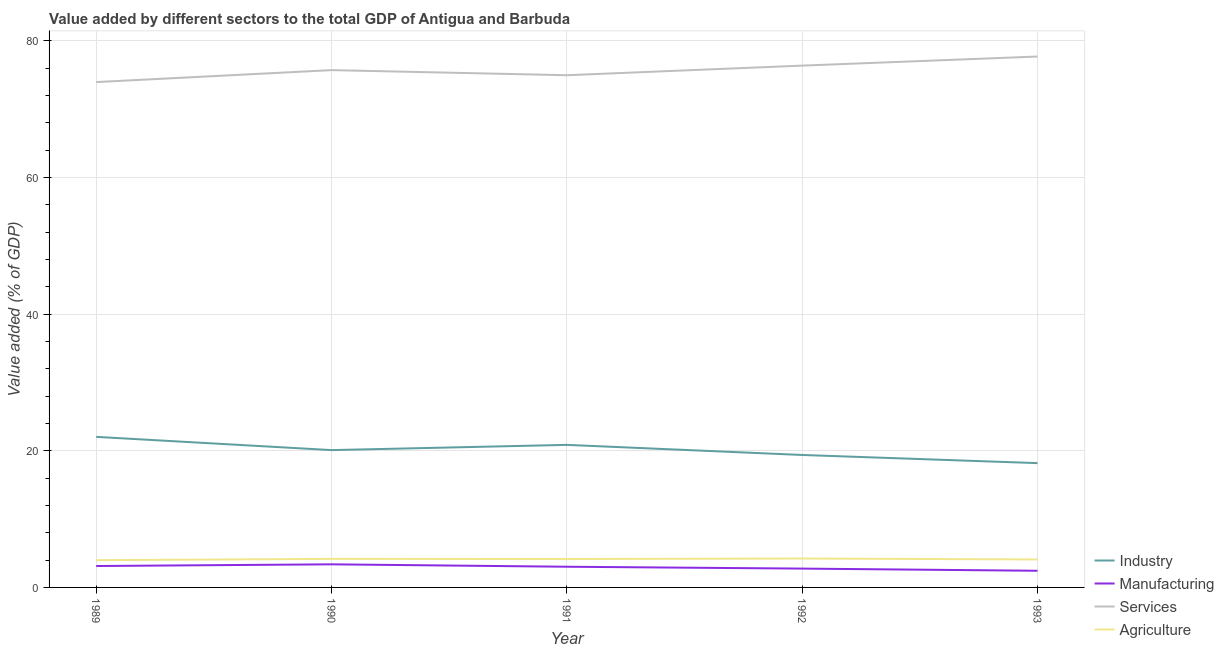How many different coloured lines are there?
Offer a terse response. 4. Does the line corresponding to value added by agricultural sector intersect with the line corresponding to value added by manufacturing sector?
Your response must be concise. No. What is the value added by manufacturing sector in 1990?
Offer a terse response. 3.38. Across all years, what is the maximum value added by manufacturing sector?
Provide a short and direct response. 3.38. Across all years, what is the minimum value added by services sector?
Provide a succinct answer. 73.97. In which year was the value added by services sector maximum?
Keep it short and to the point. 1993. What is the total value added by industrial sector in the graph?
Give a very brief answer. 100.59. What is the difference between the value added by agricultural sector in 1990 and that in 1993?
Your response must be concise. 0.08. What is the difference between the value added by services sector in 1989 and the value added by agricultural sector in 1990?
Your response must be concise. 69.79. What is the average value added by services sector per year?
Your answer should be compact. 75.75. In the year 1991, what is the difference between the value added by industrial sector and value added by agricultural sector?
Ensure brevity in your answer.  16.71. What is the ratio of the value added by services sector in 1990 to that in 1992?
Ensure brevity in your answer.  0.99. What is the difference between the highest and the second highest value added by agricultural sector?
Your answer should be very brief. 0.05. What is the difference between the highest and the lowest value added by industrial sector?
Provide a succinct answer. 3.84. Is it the case that in every year, the sum of the value added by manufacturing sector and value added by industrial sector is greater than the sum of value added by services sector and value added by agricultural sector?
Your answer should be very brief. Yes. Is it the case that in every year, the sum of the value added by industrial sector and value added by manufacturing sector is greater than the value added by services sector?
Ensure brevity in your answer.  No. Does the value added by manufacturing sector monotonically increase over the years?
Keep it short and to the point. No. Is the value added by services sector strictly greater than the value added by manufacturing sector over the years?
Your answer should be compact. Yes. How many years are there in the graph?
Your answer should be very brief. 5. What is the difference between two consecutive major ticks on the Y-axis?
Provide a succinct answer. 20. Does the graph contain any zero values?
Offer a terse response. No. How many legend labels are there?
Your answer should be very brief. 4. What is the title of the graph?
Give a very brief answer. Value added by different sectors to the total GDP of Antigua and Barbuda. Does "International Monetary Fund" appear as one of the legend labels in the graph?
Your answer should be very brief. No. What is the label or title of the Y-axis?
Your response must be concise. Value added (% of GDP). What is the Value added (% of GDP) of Industry in 1989?
Give a very brief answer. 22.04. What is the Value added (% of GDP) in Manufacturing in 1989?
Your answer should be very brief. 3.13. What is the Value added (% of GDP) in Services in 1989?
Provide a short and direct response. 73.97. What is the Value added (% of GDP) of Agriculture in 1989?
Your answer should be compact. 3.99. What is the Value added (% of GDP) of Industry in 1990?
Keep it short and to the point. 20.1. What is the Value added (% of GDP) in Manufacturing in 1990?
Offer a very short reply. 3.38. What is the Value added (% of GDP) of Services in 1990?
Ensure brevity in your answer.  75.72. What is the Value added (% of GDP) of Agriculture in 1990?
Offer a very short reply. 4.18. What is the Value added (% of GDP) in Industry in 1991?
Make the answer very short. 20.87. What is the Value added (% of GDP) of Manufacturing in 1991?
Provide a short and direct response. 3.03. What is the Value added (% of GDP) of Services in 1991?
Provide a succinct answer. 74.98. What is the Value added (% of GDP) of Agriculture in 1991?
Make the answer very short. 4.16. What is the Value added (% of GDP) in Industry in 1992?
Your response must be concise. 19.39. What is the Value added (% of GDP) of Manufacturing in 1992?
Give a very brief answer. 2.76. What is the Value added (% of GDP) in Services in 1992?
Keep it short and to the point. 76.38. What is the Value added (% of GDP) in Agriculture in 1992?
Give a very brief answer. 4.23. What is the Value added (% of GDP) of Industry in 1993?
Provide a succinct answer. 18.19. What is the Value added (% of GDP) in Manufacturing in 1993?
Keep it short and to the point. 2.44. What is the Value added (% of GDP) of Services in 1993?
Keep it short and to the point. 77.71. What is the Value added (% of GDP) of Agriculture in 1993?
Ensure brevity in your answer.  4.1. Across all years, what is the maximum Value added (% of GDP) of Industry?
Offer a terse response. 22.04. Across all years, what is the maximum Value added (% of GDP) in Manufacturing?
Ensure brevity in your answer.  3.38. Across all years, what is the maximum Value added (% of GDP) of Services?
Your answer should be very brief. 77.71. Across all years, what is the maximum Value added (% of GDP) of Agriculture?
Your answer should be very brief. 4.23. Across all years, what is the minimum Value added (% of GDP) of Industry?
Your answer should be very brief. 18.19. Across all years, what is the minimum Value added (% of GDP) of Manufacturing?
Ensure brevity in your answer.  2.44. Across all years, what is the minimum Value added (% of GDP) of Services?
Offer a very short reply. 73.97. Across all years, what is the minimum Value added (% of GDP) in Agriculture?
Offer a very short reply. 3.99. What is the total Value added (% of GDP) of Industry in the graph?
Offer a terse response. 100.59. What is the total Value added (% of GDP) of Manufacturing in the graph?
Offer a very short reply. 14.74. What is the total Value added (% of GDP) in Services in the graph?
Provide a short and direct response. 378.76. What is the total Value added (% of GDP) of Agriculture in the graph?
Your answer should be very brief. 20.65. What is the difference between the Value added (% of GDP) in Industry in 1989 and that in 1990?
Offer a terse response. 1.94. What is the difference between the Value added (% of GDP) of Manufacturing in 1989 and that in 1990?
Offer a very short reply. -0.25. What is the difference between the Value added (% of GDP) of Services in 1989 and that in 1990?
Your answer should be compact. -1.75. What is the difference between the Value added (% of GDP) of Agriculture in 1989 and that in 1990?
Your answer should be compact. -0.19. What is the difference between the Value added (% of GDP) of Industry in 1989 and that in 1991?
Ensure brevity in your answer.  1.17. What is the difference between the Value added (% of GDP) of Manufacturing in 1989 and that in 1991?
Your answer should be very brief. 0.11. What is the difference between the Value added (% of GDP) in Services in 1989 and that in 1991?
Your answer should be very brief. -1. What is the difference between the Value added (% of GDP) of Agriculture in 1989 and that in 1991?
Give a very brief answer. -0.17. What is the difference between the Value added (% of GDP) of Industry in 1989 and that in 1992?
Your response must be concise. 2.65. What is the difference between the Value added (% of GDP) of Manufacturing in 1989 and that in 1992?
Offer a terse response. 0.38. What is the difference between the Value added (% of GDP) in Services in 1989 and that in 1992?
Offer a terse response. -2.41. What is the difference between the Value added (% of GDP) in Agriculture in 1989 and that in 1992?
Offer a very short reply. -0.24. What is the difference between the Value added (% of GDP) of Industry in 1989 and that in 1993?
Offer a very short reply. 3.84. What is the difference between the Value added (% of GDP) of Manufacturing in 1989 and that in 1993?
Give a very brief answer. 0.7. What is the difference between the Value added (% of GDP) in Services in 1989 and that in 1993?
Offer a terse response. -3.74. What is the difference between the Value added (% of GDP) of Agriculture in 1989 and that in 1993?
Make the answer very short. -0.11. What is the difference between the Value added (% of GDP) of Industry in 1990 and that in 1991?
Make the answer very short. -0.77. What is the difference between the Value added (% of GDP) of Manufacturing in 1990 and that in 1991?
Keep it short and to the point. 0.35. What is the difference between the Value added (% of GDP) in Services in 1990 and that in 1991?
Your response must be concise. 0.74. What is the difference between the Value added (% of GDP) in Agriculture in 1990 and that in 1991?
Give a very brief answer. 0.02. What is the difference between the Value added (% of GDP) in Industry in 1990 and that in 1992?
Your answer should be very brief. 0.71. What is the difference between the Value added (% of GDP) of Manufacturing in 1990 and that in 1992?
Provide a succinct answer. 0.62. What is the difference between the Value added (% of GDP) of Services in 1990 and that in 1992?
Ensure brevity in your answer.  -0.66. What is the difference between the Value added (% of GDP) in Agriculture in 1990 and that in 1992?
Provide a short and direct response. -0.05. What is the difference between the Value added (% of GDP) in Industry in 1990 and that in 1993?
Give a very brief answer. 1.91. What is the difference between the Value added (% of GDP) of Manufacturing in 1990 and that in 1993?
Ensure brevity in your answer.  0.94. What is the difference between the Value added (% of GDP) of Services in 1990 and that in 1993?
Give a very brief answer. -1.99. What is the difference between the Value added (% of GDP) in Agriculture in 1990 and that in 1993?
Give a very brief answer. 0.08. What is the difference between the Value added (% of GDP) in Industry in 1991 and that in 1992?
Keep it short and to the point. 1.48. What is the difference between the Value added (% of GDP) of Manufacturing in 1991 and that in 1992?
Your answer should be compact. 0.27. What is the difference between the Value added (% of GDP) in Services in 1991 and that in 1992?
Provide a succinct answer. -1.4. What is the difference between the Value added (% of GDP) of Agriculture in 1991 and that in 1992?
Give a very brief answer. -0.07. What is the difference between the Value added (% of GDP) in Industry in 1991 and that in 1993?
Your answer should be very brief. 2.67. What is the difference between the Value added (% of GDP) in Manufacturing in 1991 and that in 1993?
Offer a terse response. 0.59. What is the difference between the Value added (% of GDP) in Services in 1991 and that in 1993?
Provide a succinct answer. -2.73. What is the difference between the Value added (% of GDP) in Agriculture in 1991 and that in 1993?
Your response must be concise. 0.06. What is the difference between the Value added (% of GDP) in Industry in 1992 and that in 1993?
Keep it short and to the point. 1.19. What is the difference between the Value added (% of GDP) of Manufacturing in 1992 and that in 1993?
Make the answer very short. 0.32. What is the difference between the Value added (% of GDP) of Services in 1992 and that in 1993?
Make the answer very short. -1.33. What is the difference between the Value added (% of GDP) of Agriculture in 1992 and that in 1993?
Give a very brief answer. 0.14. What is the difference between the Value added (% of GDP) in Industry in 1989 and the Value added (% of GDP) in Manufacturing in 1990?
Ensure brevity in your answer.  18.66. What is the difference between the Value added (% of GDP) of Industry in 1989 and the Value added (% of GDP) of Services in 1990?
Keep it short and to the point. -53.68. What is the difference between the Value added (% of GDP) in Industry in 1989 and the Value added (% of GDP) in Agriculture in 1990?
Provide a succinct answer. 17.86. What is the difference between the Value added (% of GDP) in Manufacturing in 1989 and the Value added (% of GDP) in Services in 1990?
Your response must be concise. -72.59. What is the difference between the Value added (% of GDP) in Manufacturing in 1989 and the Value added (% of GDP) in Agriculture in 1990?
Make the answer very short. -1.04. What is the difference between the Value added (% of GDP) of Services in 1989 and the Value added (% of GDP) of Agriculture in 1990?
Give a very brief answer. 69.79. What is the difference between the Value added (% of GDP) of Industry in 1989 and the Value added (% of GDP) of Manufacturing in 1991?
Make the answer very short. 19.01. What is the difference between the Value added (% of GDP) in Industry in 1989 and the Value added (% of GDP) in Services in 1991?
Offer a very short reply. -52.94. What is the difference between the Value added (% of GDP) of Industry in 1989 and the Value added (% of GDP) of Agriculture in 1991?
Give a very brief answer. 17.88. What is the difference between the Value added (% of GDP) in Manufacturing in 1989 and the Value added (% of GDP) in Services in 1991?
Provide a succinct answer. -71.84. What is the difference between the Value added (% of GDP) in Manufacturing in 1989 and the Value added (% of GDP) in Agriculture in 1991?
Offer a terse response. -1.02. What is the difference between the Value added (% of GDP) in Services in 1989 and the Value added (% of GDP) in Agriculture in 1991?
Make the answer very short. 69.81. What is the difference between the Value added (% of GDP) of Industry in 1989 and the Value added (% of GDP) of Manufacturing in 1992?
Your answer should be very brief. 19.28. What is the difference between the Value added (% of GDP) in Industry in 1989 and the Value added (% of GDP) in Services in 1992?
Give a very brief answer. -54.34. What is the difference between the Value added (% of GDP) in Industry in 1989 and the Value added (% of GDP) in Agriculture in 1992?
Your answer should be very brief. 17.81. What is the difference between the Value added (% of GDP) of Manufacturing in 1989 and the Value added (% of GDP) of Services in 1992?
Offer a very short reply. -73.25. What is the difference between the Value added (% of GDP) of Manufacturing in 1989 and the Value added (% of GDP) of Agriculture in 1992?
Your answer should be very brief. -1.1. What is the difference between the Value added (% of GDP) of Services in 1989 and the Value added (% of GDP) of Agriculture in 1992?
Give a very brief answer. 69.74. What is the difference between the Value added (% of GDP) of Industry in 1989 and the Value added (% of GDP) of Manufacturing in 1993?
Offer a very short reply. 19.6. What is the difference between the Value added (% of GDP) of Industry in 1989 and the Value added (% of GDP) of Services in 1993?
Ensure brevity in your answer.  -55.67. What is the difference between the Value added (% of GDP) of Industry in 1989 and the Value added (% of GDP) of Agriculture in 1993?
Ensure brevity in your answer.  17.94. What is the difference between the Value added (% of GDP) of Manufacturing in 1989 and the Value added (% of GDP) of Services in 1993?
Offer a terse response. -74.58. What is the difference between the Value added (% of GDP) of Manufacturing in 1989 and the Value added (% of GDP) of Agriculture in 1993?
Your answer should be compact. -0.96. What is the difference between the Value added (% of GDP) in Services in 1989 and the Value added (% of GDP) in Agriculture in 1993?
Keep it short and to the point. 69.88. What is the difference between the Value added (% of GDP) in Industry in 1990 and the Value added (% of GDP) in Manufacturing in 1991?
Your answer should be very brief. 17.07. What is the difference between the Value added (% of GDP) of Industry in 1990 and the Value added (% of GDP) of Services in 1991?
Your answer should be compact. -54.88. What is the difference between the Value added (% of GDP) in Industry in 1990 and the Value added (% of GDP) in Agriculture in 1991?
Your answer should be very brief. 15.94. What is the difference between the Value added (% of GDP) in Manufacturing in 1990 and the Value added (% of GDP) in Services in 1991?
Make the answer very short. -71.6. What is the difference between the Value added (% of GDP) of Manufacturing in 1990 and the Value added (% of GDP) of Agriculture in 1991?
Make the answer very short. -0.78. What is the difference between the Value added (% of GDP) of Services in 1990 and the Value added (% of GDP) of Agriculture in 1991?
Offer a terse response. 71.56. What is the difference between the Value added (% of GDP) in Industry in 1990 and the Value added (% of GDP) in Manufacturing in 1992?
Give a very brief answer. 17.34. What is the difference between the Value added (% of GDP) in Industry in 1990 and the Value added (% of GDP) in Services in 1992?
Your response must be concise. -56.28. What is the difference between the Value added (% of GDP) in Industry in 1990 and the Value added (% of GDP) in Agriculture in 1992?
Your answer should be compact. 15.87. What is the difference between the Value added (% of GDP) in Manufacturing in 1990 and the Value added (% of GDP) in Services in 1992?
Make the answer very short. -73. What is the difference between the Value added (% of GDP) in Manufacturing in 1990 and the Value added (% of GDP) in Agriculture in 1992?
Your response must be concise. -0.85. What is the difference between the Value added (% of GDP) in Services in 1990 and the Value added (% of GDP) in Agriculture in 1992?
Your answer should be very brief. 71.49. What is the difference between the Value added (% of GDP) of Industry in 1990 and the Value added (% of GDP) of Manufacturing in 1993?
Keep it short and to the point. 17.66. What is the difference between the Value added (% of GDP) of Industry in 1990 and the Value added (% of GDP) of Services in 1993?
Ensure brevity in your answer.  -57.61. What is the difference between the Value added (% of GDP) in Industry in 1990 and the Value added (% of GDP) in Agriculture in 1993?
Give a very brief answer. 16.01. What is the difference between the Value added (% of GDP) of Manufacturing in 1990 and the Value added (% of GDP) of Services in 1993?
Offer a terse response. -74.33. What is the difference between the Value added (% of GDP) of Manufacturing in 1990 and the Value added (% of GDP) of Agriculture in 1993?
Offer a terse response. -0.71. What is the difference between the Value added (% of GDP) of Services in 1990 and the Value added (% of GDP) of Agriculture in 1993?
Offer a terse response. 71.63. What is the difference between the Value added (% of GDP) of Industry in 1991 and the Value added (% of GDP) of Manufacturing in 1992?
Provide a short and direct response. 18.11. What is the difference between the Value added (% of GDP) of Industry in 1991 and the Value added (% of GDP) of Services in 1992?
Keep it short and to the point. -55.51. What is the difference between the Value added (% of GDP) in Industry in 1991 and the Value added (% of GDP) in Agriculture in 1992?
Offer a very short reply. 16.64. What is the difference between the Value added (% of GDP) in Manufacturing in 1991 and the Value added (% of GDP) in Services in 1992?
Keep it short and to the point. -73.35. What is the difference between the Value added (% of GDP) of Manufacturing in 1991 and the Value added (% of GDP) of Agriculture in 1992?
Your answer should be very brief. -1.2. What is the difference between the Value added (% of GDP) in Services in 1991 and the Value added (% of GDP) in Agriculture in 1992?
Make the answer very short. 70.75. What is the difference between the Value added (% of GDP) of Industry in 1991 and the Value added (% of GDP) of Manufacturing in 1993?
Keep it short and to the point. 18.43. What is the difference between the Value added (% of GDP) in Industry in 1991 and the Value added (% of GDP) in Services in 1993?
Offer a very short reply. -56.84. What is the difference between the Value added (% of GDP) of Industry in 1991 and the Value added (% of GDP) of Agriculture in 1993?
Offer a very short reply. 16.77. What is the difference between the Value added (% of GDP) in Manufacturing in 1991 and the Value added (% of GDP) in Services in 1993?
Make the answer very short. -74.68. What is the difference between the Value added (% of GDP) in Manufacturing in 1991 and the Value added (% of GDP) in Agriculture in 1993?
Make the answer very short. -1.07. What is the difference between the Value added (% of GDP) in Services in 1991 and the Value added (% of GDP) in Agriculture in 1993?
Make the answer very short. 70.88. What is the difference between the Value added (% of GDP) in Industry in 1992 and the Value added (% of GDP) in Manufacturing in 1993?
Offer a terse response. 16.95. What is the difference between the Value added (% of GDP) in Industry in 1992 and the Value added (% of GDP) in Services in 1993?
Ensure brevity in your answer.  -58.32. What is the difference between the Value added (% of GDP) of Industry in 1992 and the Value added (% of GDP) of Agriculture in 1993?
Your answer should be compact. 15.29. What is the difference between the Value added (% of GDP) in Manufacturing in 1992 and the Value added (% of GDP) in Services in 1993?
Make the answer very short. -74.95. What is the difference between the Value added (% of GDP) of Manufacturing in 1992 and the Value added (% of GDP) of Agriculture in 1993?
Provide a short and direct response. -1.34. What is the difference between the Value added (% of GDP) of Services in 1992 and the Value added (% of GDP) of Agriculture in 1993?
Keep it short and to the point. 72.29. What is the average Value added (% of GDP) in Industry per year?
Provide a short and direct response. 20.12. What is the average Value added (% of GDP) in Manufacturing per year?
Your answer should be very brief. 2.95. What is the average Value added (% of GDP) of Services per year?
Keep it short and to the point. 75.75. What is the average Value added (% of GDP) in Agriculture per year?
Provide a succinct answer. 4.13. In the year 1989, what is the difference between the Value added (% of GDP) of Industry and Value added (% of GDP) of Manufacturing?
Offer a terse response. 18.9. In the year 1989, what is the difference between the Value added (% of GDP) in Industry and Value added (% of GDP) in Services?
Make the answer very short. -51.93. In the year 1989, what is the difference between the Value added (% of GDP) in Industry and Value added (% of GDP) in Agriculture?
Provide a short and direct response. 18.05. In the year 1989, what is the difference between the Value added (% of GDP) in Manufacturing and Value added (% of GDP) in Services?
Provide a succinct answer. -70.84. In the year 1989, what is the difference between the Value added (% of GDP) in Manufacturing and Value added (% of GDP) in Agriculture?
Your response must be concise. -0.86. In the year 1989, what is the difference between the Value added (% of GDP) of Services and Value added (% of GDP) of Agriculture?
Provide a short and direct response. 69.98. In the year 1990, what is the difference between the Value added (% of GDP) of Industry and Value added (% of GDP) of Manufacturing?
Offer a very short reply. 16.72. In the year 1990, what is the difference between the Value added (% of GDP) in Industry and Value added (% of GDP) in Services?
Give a very brief answer. -55.62. In the year 1990, what is the difference between the Value added (% of GDP) of Industry and Value added (% of GDP) of Agriculture?
Provide a succinct answer. 15.92. In the year 1990, what is the difference between the Value added (% of GDP) in Manufacturing and Value added (% of GDP) in Services?
Provide a short and direct response. -72.34. In the year 1990, what is the difference between the Value added (% of GDP) of Manufacturing and Value added (% of GDP) of Agriculture?
Ensure brevity in your answer.  -0.8. In the year 1990, what is the difference between the Value added (% of GDP) of Services and Value added (% of GDP) of Agriculture?
Give a very brief answer. 71.54. In the year 1991, what is the difference between the Value added (% of GDP) in Industry and Value added (% of GDP) in Manufacturing?
Ensure brevity in your answer.  17.84. In the year 1991, what is the difference between the Value added (% of GDP) in Industry and Value added (% of GDP) in Services?
Make the answer very short. -54.11. In the year 1991, what is the difference between the Value added (% of GDP) of Industry and Value added (% of GDP) of Agriculture?
Keep it short and to the point. 16.71. In the year 1991, what is the difference between the Value added (% of GDP) of Manufacturing and Value added (% of GDP) of Services?
Provide a short and direct response. -71.95. In the year 1991, what is the difference between the Value added (% of GDP) in Manufacturing and Value added (% of GDP) in Agriculture?
Give a very brief answer. -1.13. In the year 1991, what is the difference between the Value added (% of GDP) of Services and Value added (% of GDP) of Agriculture?
Give a very brief answer. 70.82. In the year 1992, what is the difference between the Value added (% of GDP) of Industry and Value added (% of GDP) of Manufacturing?
Provide a succinct answer. 16.63. In the year 1992, what is the difference between the Value added (% of GDP) of Industry and Value added (% of GDP) of Services?
Offer a terse response. -56.99. In the year 1992, what is the difference between the Value added (% of GDP) in Industry and Value added (% of GDP) in Agriculture?
Provide a short and direct response. 15.16. In the year 1992, what is the difference between the Value added (% of GDP) of Manufacturing and Value added (% of GDP) of Services?
Your answer should be compact. -73.62. In the year 1992, what is the difference between the Value added (% of GDP) of Manufacturing and Value added (% of GDP) of Agriculture?
Keep it short and to the point. -1.47. In the year 1992, what is the difference between the Value added (% of GDP) in Services and Value added (% of GDP) in Agriculture?
Offer a terse response. 72.15. In the year 1993, what is the difference between the Value added (% of GDP) of Industry and Value added (% of GDP) of Manufacturing?
Give a very brief answer. 15.76. In the year 1993, what is the difference between the Value added (% of GDP) in Industry and Value added (% of GDP) in Services?
Keep it short and to the point. -59.52. In the year 1993, what is the difference between the Value added (% of GDP) of Industry and Value added (% of GDP) of Agriculture?
Keep it short and to the point. 14.1. In the year 1993, what is the difference between the Value added (% of GDP) in Manufacturing and Value added (% of GDP) in Services?
Your answer should be very brief. -75.27. In the year 1993, what is the difference between the Value added (% of GDP) in Manufacturing and Value added (% of GDP) in Agriculture?
Offer a very short reply. -1.66. In the year 1993, what is the difference between the Value added (% of GDP) in Services and Value added (% of GDP) in Agriculture?
Make the answer very short. 73.61. What is the ratio of the Value added (% of GDP) in Industry in 1989 to that in 1990?
Ensure brevity in your answer.  1.1. What is the ratio of the Value added (% of GDP) in Manufacturing in 1989 to that in 1990?
Make the answer very short. 0.93. What is the ratio of the Value added (% of GDP) of Services in 1989 to that in 1990?
Provide a short and direct response. 0.98. What is the ratio of the Value added (% of GDP) in Agriculture in 1989 to that in 1990?
Give a very brief answer. 0.96. What is the ratio of the Value added (% of GDP) in Industry in 1989 to that in 1991?
Your response must be concise. 1.06. What is the ratio of the Value added (% of GDP) of Manufacturing in 1989 to that in 1991?
Your answer should be very brief. 1.04. What is the ratio of the Value added (% of GDP) in Services in 1989 to that in 1991?
Your answer should be compact. 0.99. What is the ratio of the Value added (% of GDP) in Agriculture in 1989 to that in 1991?
Offer a very short reply. 0.96. What is the ratio of the Value added (% of GDP) of Industry in 1989 to that in 1992?
Keep it short and to the point. 1.14. What is the ratio of the Value added (% of GDP) in Manufacturing in 1989 to that in 1992?
Ensure brevity in your answer.  1.14. What is the ratio of the Value added (% of GDP) of Services in 1989 to that in 1992?
Make the answer very short. 0.97. What is the ratio of the Value added (% of GDP) in Agriculture in 1989 to that in 1992?
Provide a short and direct response. 0.94. What is the ratio of the Value added (% of GDP) in Industry in 1989 to that in 1993?
Provide a short and direct response. 1.21. What is the ratio of the Value added (% of GDP) in Manufacturing in 1989 to that in 1993?
Make the answer very short. 1.29. What is the ratio of the Value added (% of GDP) in Services in 1989 to that in 1993?
Your answer should be very brief. 0.95. What is the ratio of the Value added (% of GDP) of Agriculture in 1989 to that in 1993?
Provide a short and direct response. 0.97. What is the ratio of the Value added (% of GDP) in Industry in 1990 to that in 1991?
Ensure brevity in your answer.  0.96. What is the ratio of the Value added (% of GDP) in Manufacturing in 1990 to that in 1991?
Provide a succinct answer. 1.12. What is the ratio of the Value added (% of GDP) in Services in 1990 to that in 1991?
Give a very brief answer. 1.01. What is the ratio of the Value added (% of GDP) of Industry in 1990 to that in 1992?
Provide a short and direct response. 1.04. What is the ratio of the Value added (% of GDP) in Manufacturing in 1990 to that in 1992?
Ensure brevity in your answer.  1.23. What is the ratio of the Value added (% of GDP) in Services in 1990 to that in 1992?
Offer a terse response. 0.99. What is the ratio of the Value added (% of GDP) in Agriculture in 1990 to that in 1992?
Your answer should be very brief. 0.99. What is the ratio of the Value added (% of GDP) of Industry in 1990 to that in 1993?
Keep it short and to the point. 1.1. What is the ratio of the Value added (% of GDP) of Manufacturing in 1990 to that in 1993?
Give a very brief answer. 1.39. What is the ratio of the Value added (% of GDP) in Services in 1990 to that in 1993?
Your answer should be compact. 0.97. What is the ratio of the Value added (% of GDP) in Agriculture in 1990 to that in 1993?
Offer a very short reply. 1.02. What is the ratio of the Value added (% of GDP) in Industry in 1991 to that in 1992?
Make the answer very short. 1.08. What is the ratio of the Value added (% of GDP) in Manufacturing in 1991 to that in 1992?
Offer a terse response. 1.1. What is the ratio of the Value added (% of GDP) in Services in 1991 to that in 1992?
Your response must be concise. 0.98. What is the ratio of the Value added (% of GDP) of Agriculture in 1991 to that in 1992?
Offer a terse response. 0.98. What is the ratio of the Value added (% of GDP) of Industry in 1991 to that in 1993?
Offer a very short reply. 1.15. What is the ratio of the Value added (% of GDP) of Manufacturing in 1991 to that in 1993?
Keep it short and to the point. 1.24. What is the ratio of the Value added (% of GDP) of Services in 1991 to that in 1993?
Give a very brief answer. 0.96. What is the ratio of the Value added (% of GDP) of Agriculture in 1991 to that in 1993?
Make the answer very short. 1.01. What is the ratio of the Value added (% of GDP) of Industry in 1992 to that in 1993?
Provide a short and direct response. 1.07. What is the ratio of the Value added (% of GDP) in Manufacturing in 1992 to that in 1993?
Your answer should be compact. 1.13. What is the ratio of the Value added (% of GDP) of Services in 1992 to that in 1993?
Give a very brief answer. 0.98. What is the ratio of the Value added (% of GDP) in Agriculture in 1992 to that in 1993?
Your response must be concise. 1.03. What is the difference between the highest and the second highest Value added (% of GDP) of Industry?
Your answer should be very brief. 1.17. What is the difference between the highest and the second highest Value added (% of GDP) of Manufacturing?
Provide a succinct answer. 0.25. What is the difference between the highest and the second highest Value added (% of GDP) in Services?
Your answer should be compact. 1.33. What is the difference between the highest and the second highest Value added (% of GDP) of Agriculture?
Give a very brief answer. 0.05. What is the difference between the highest and the lowest Value added (% of GDP) of Industry?
Ensure brevity in your answer.  3.84. What is the difference between the highest and the lowest Value added (% of GDP) in Manufacturing?
Provide a succinct answer. 0.94. What is the difference between the highest and the lowest Value added (% of GDP) of Services?
Offer a very short reply. 3.74. What is the difference between the highest and the lowest Value added (% of GDP) of Agriculture?
Your answer should be compact. 0.24. 